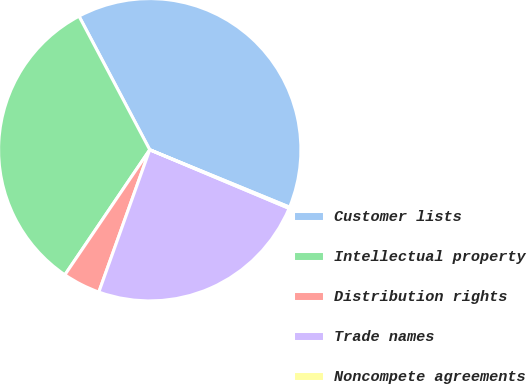Convert chart to OTSL. <chart><loc_0><loc_0><loc_500><loc_500><pie_chart><fcel>Customer lists<fcel>Intellectual property<fcel>Distribution rights<fcel>Trade names<fcel>Noncompete agreements<nl><fcel>38.95%<fcel>32.76%<fcel>4.02%<fcel>24.13%<fcel>0.14%<nl></chart> 